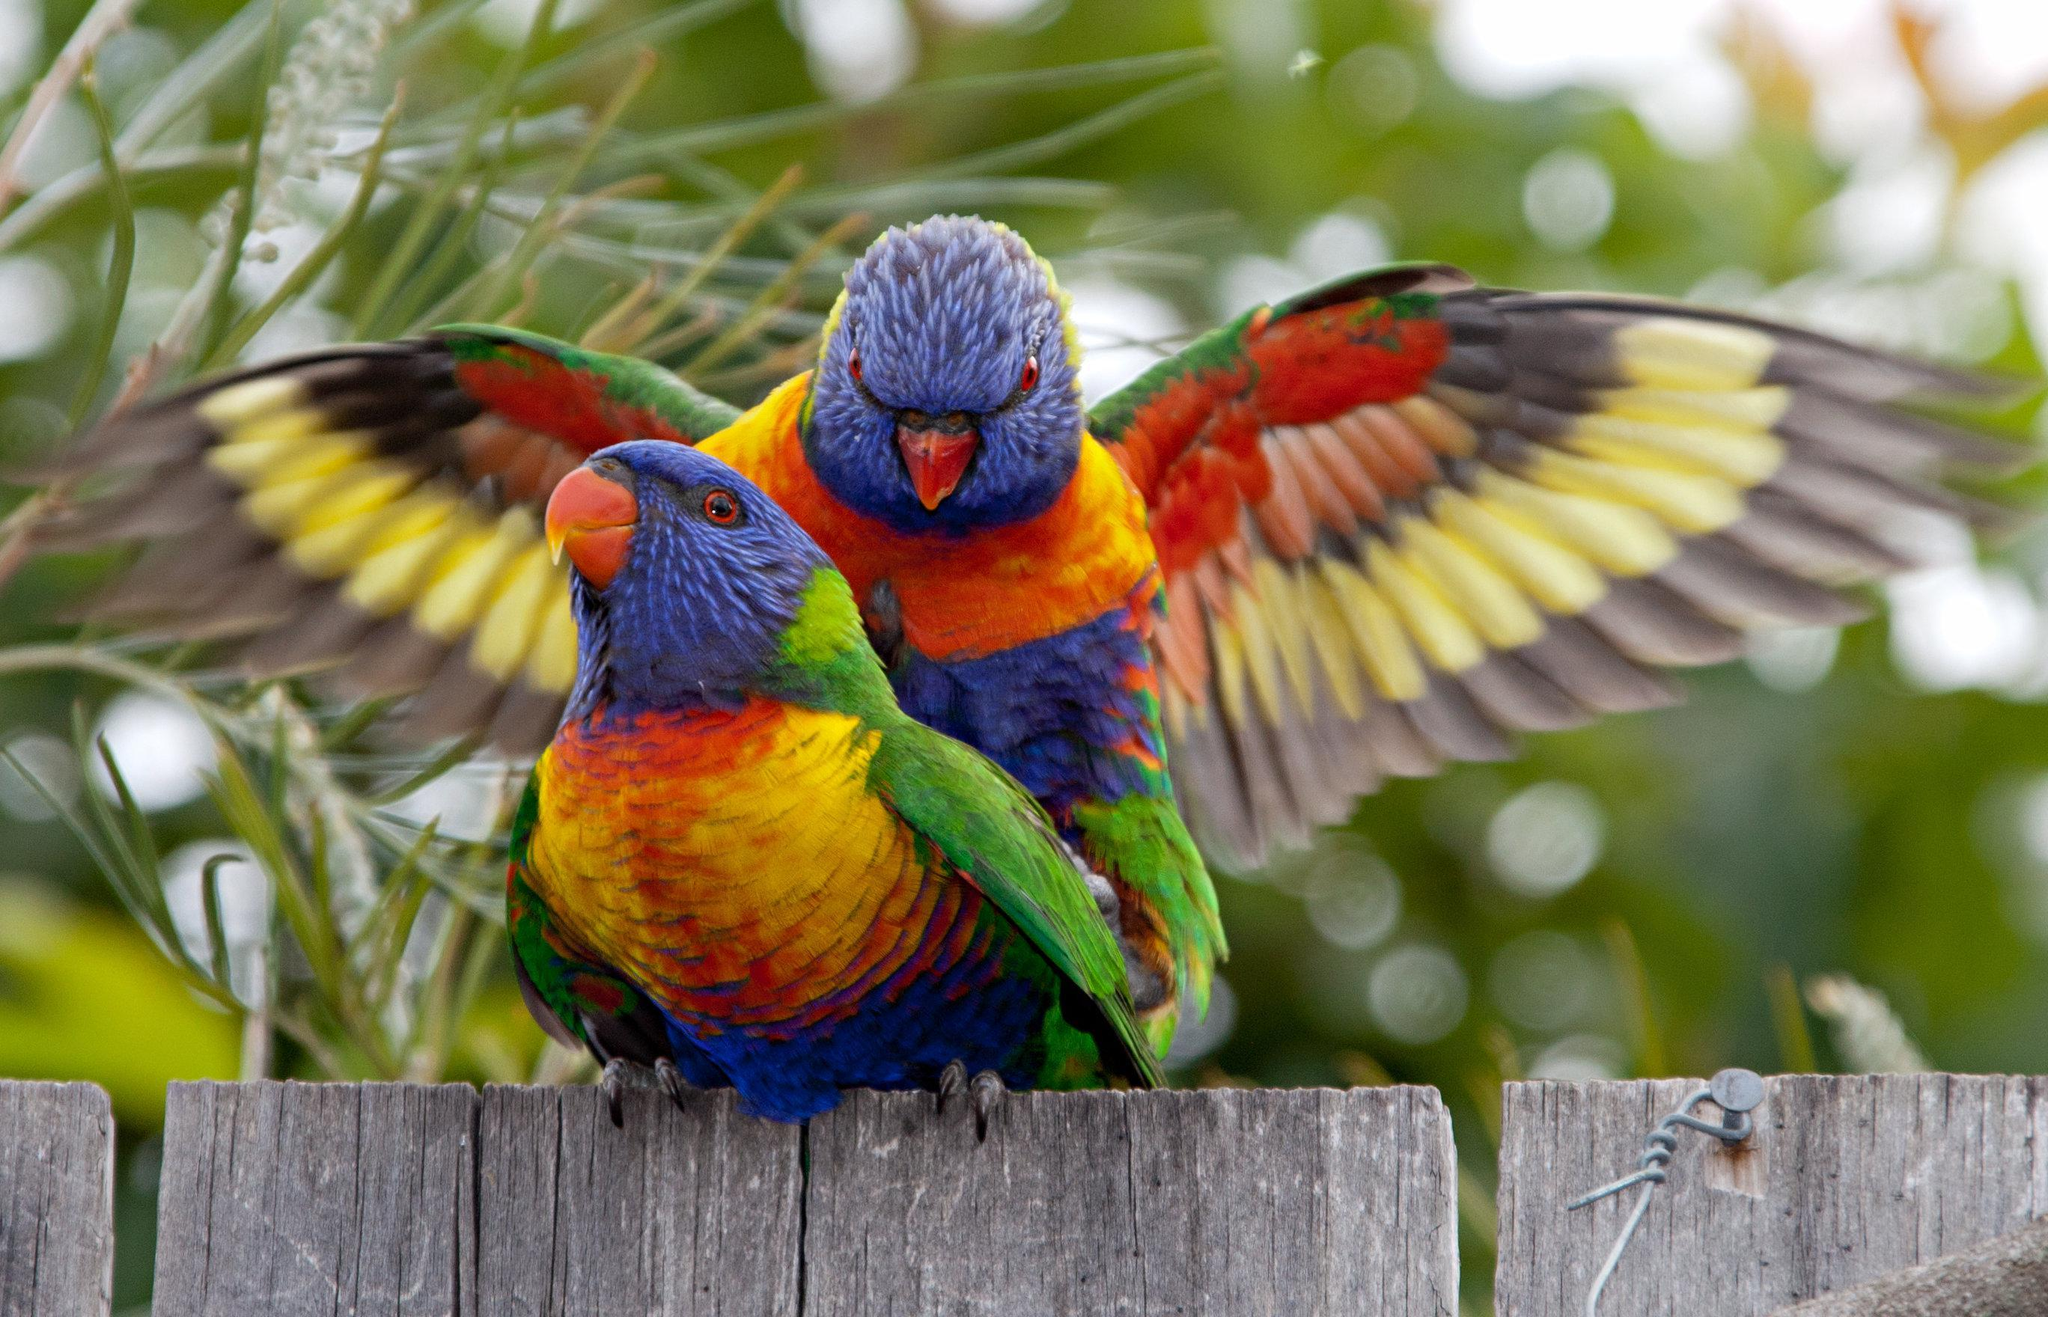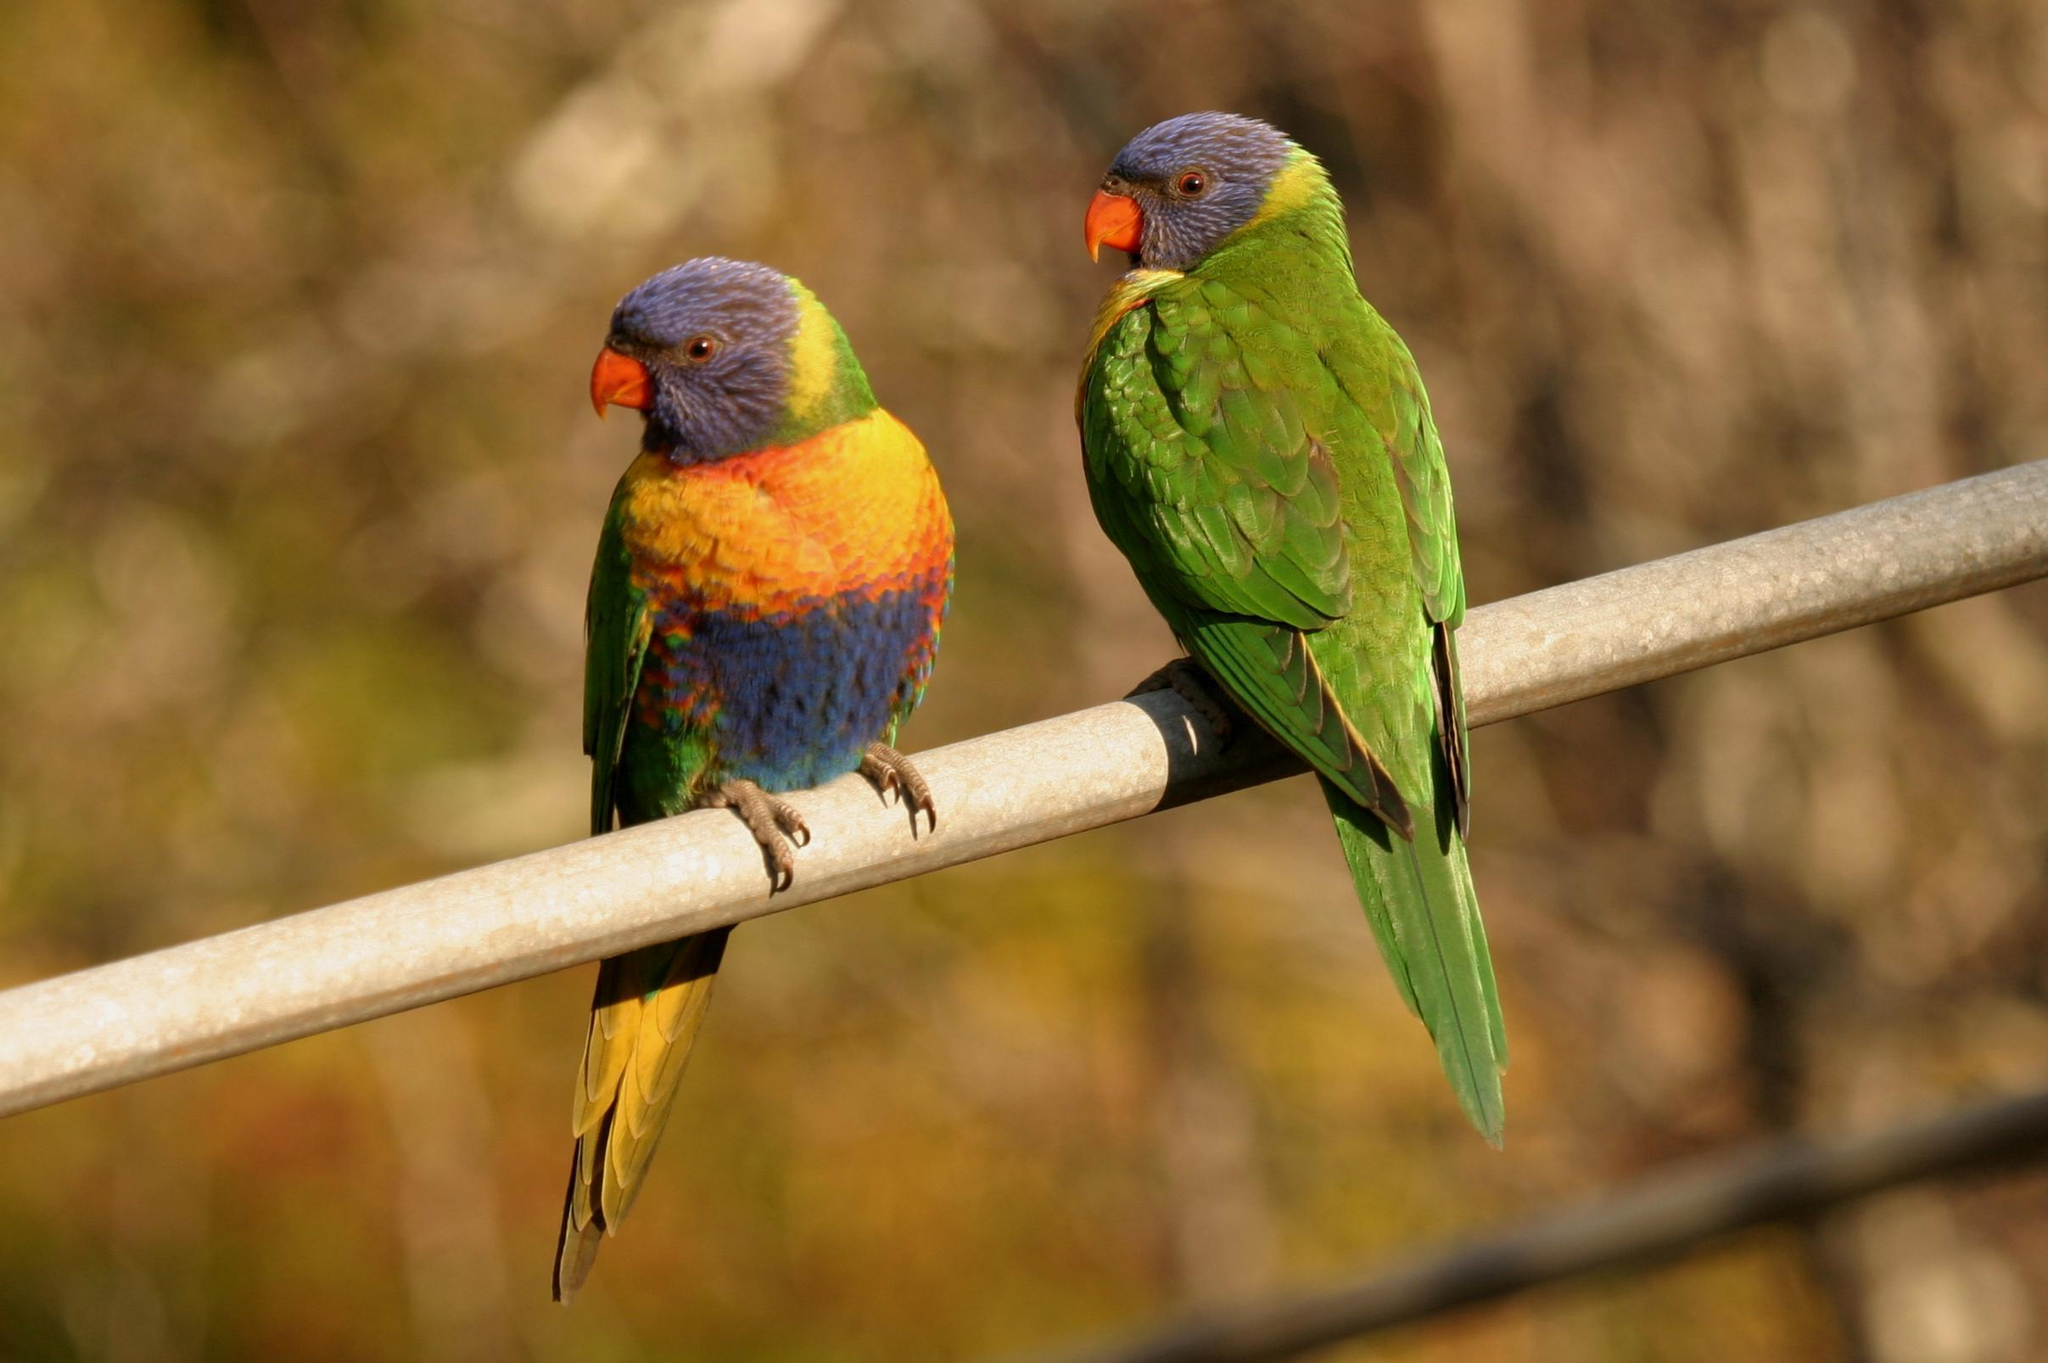The first image is the image on the left, the second image is the image on the right. For the images shown, is this caption "Exactly three parrots are seated on perches." true? Answer yes or no. No. 